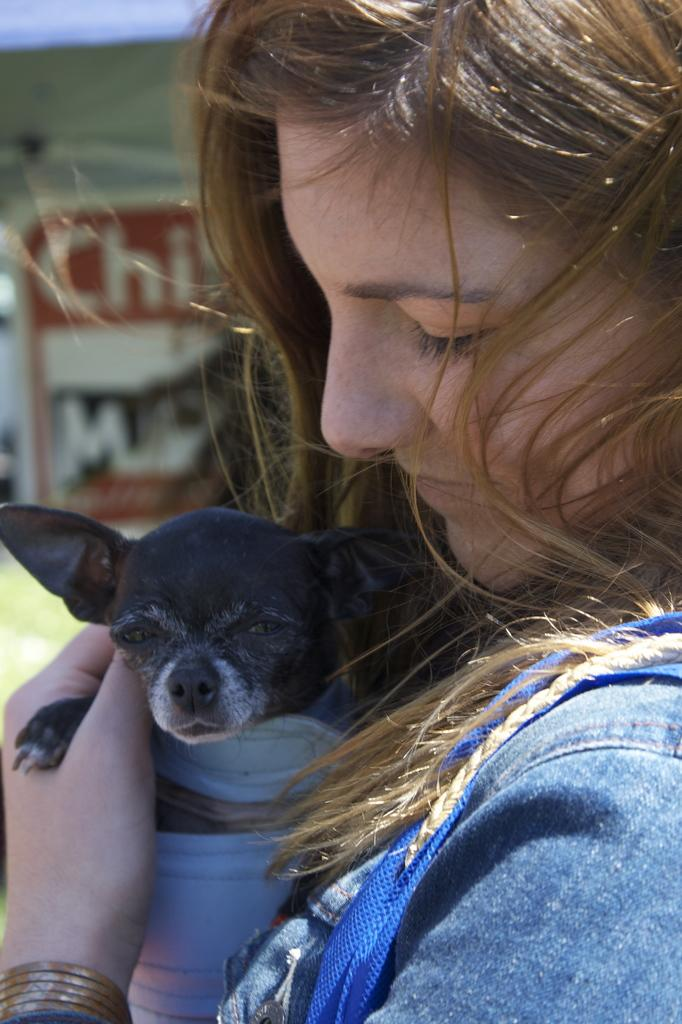What is the person in the image doing with the dog? The person is carrying a dog in the image. What type of clothing is the person wearing? The person is wearing a denim jacket. What can be seen in the background of the image? There is a banner in the background of the image. Can you tell me how many volcanoes are visible in the image? There are no volcanoes present in the image. What type of animal is being pushed in a stroller in the image? There is no animal being pushed in a stroller in the image. 